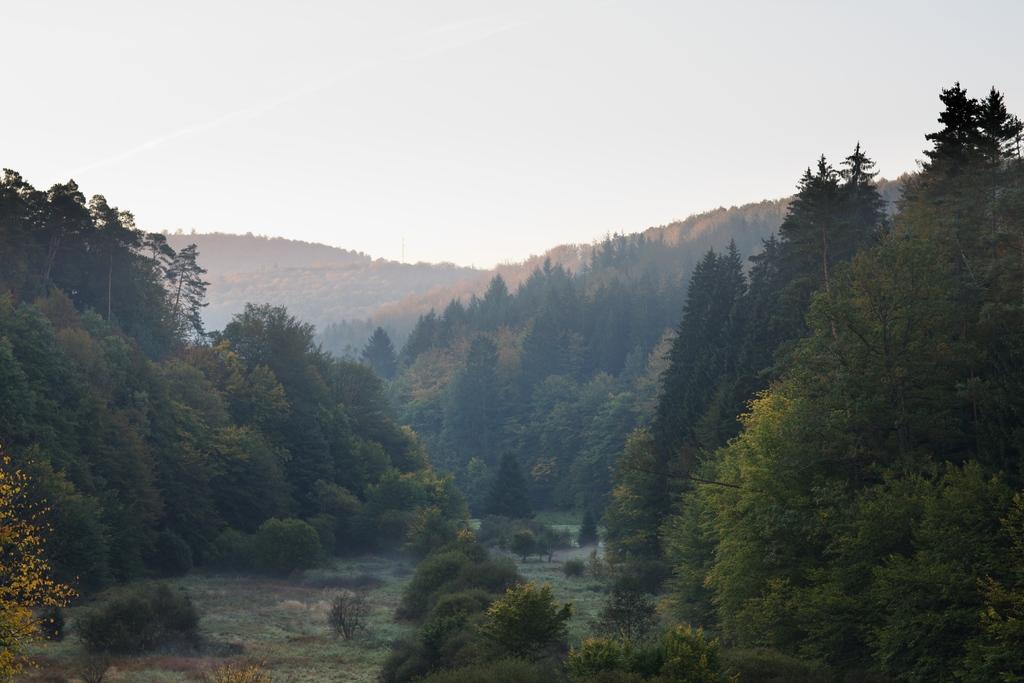What is the main subject in the middle of the image? There is land in the middle of the image. What type of vegetation is present on either side of the land? There are trees on either side of the land. What can be seen in the background of the image? The background of the image is the sky. What type of can is visible in the image? There is no can present in the image. Is there a judge standing on the land in the image? There is no judge present in the image. 